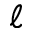<formula> <loc_0><loc_0><loc_500><loc_500>\ell</formula> 